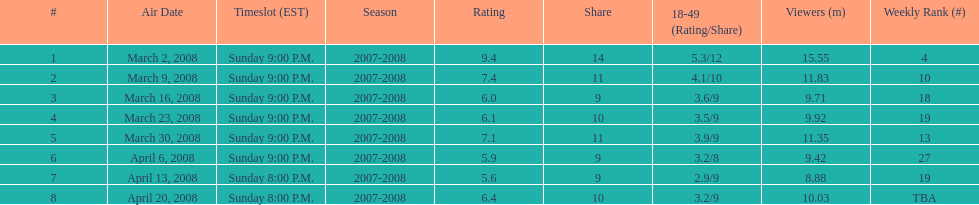In which episode was the maximum rating achieved? March 2, 2008. 